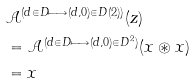Convert formula to latex. <formula><loc_0><loc_0><loc_500><loc_500>& \mathcal { A } ^ { ( d \in D \longmapsto ( d , 0 ) \in D ( 2 ) ) } ( z ) \\ & = \mathcal { A } ^ { ( d \in D \longmapsto ( d , 0 ) \in D ^ { 2 } ) } ( x \circledast x ) \\ & = x</formula> 